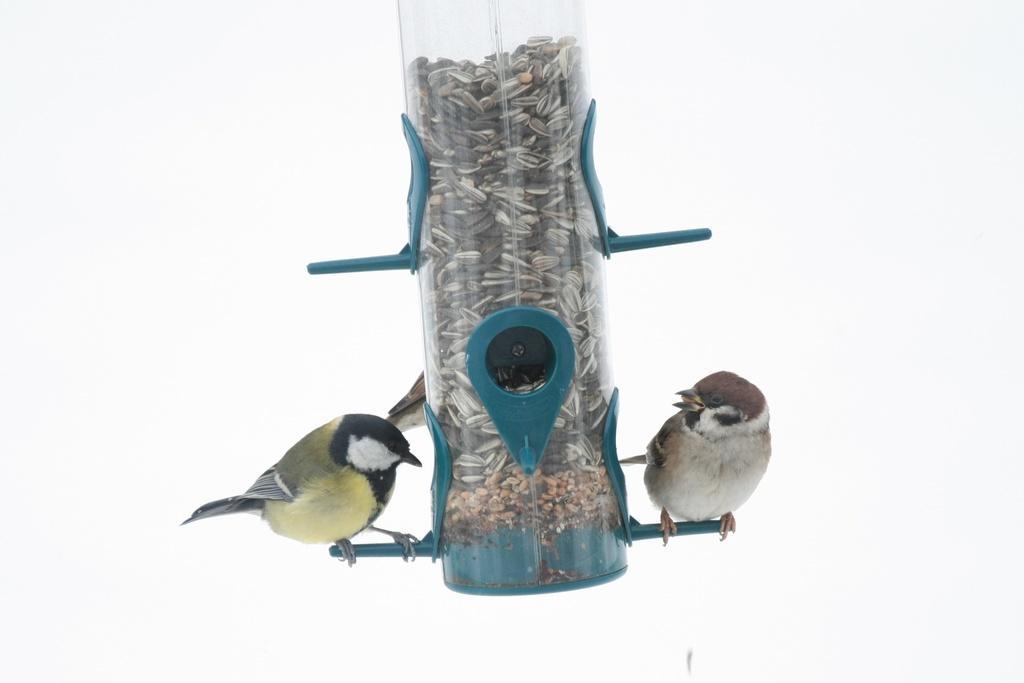Could you give a brief overview of what you see in this image? In this picture there are seeds in the object and there are two birds standing on the object. At the back there is a white background. 